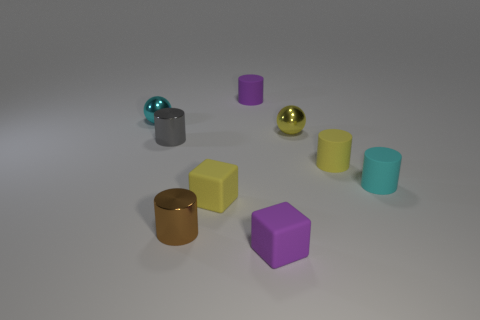The purple object that is in front of the tiny cyan object on the right side of the purple matte block is made of what material?
Make the answer very short. Rubber. How many objects are purple blocks or small rubber cubes?
Your answer should be compact. 2. Is the number of cyan metallic objects less than the number of tiny yellow matte balls?
Provide a short and direct response. No. There is a cylinder that is made of the same material as the small brown object; what size is it?
Ensure brevity in your answer.  Small. The brown metal thing has what size?
Keep it short and to the point. Small. The tiny gray metallic thing has what shape?
Your answer should be very brief. Cylinder. What is the size of the cyan rubber thing that is the same shape as the tiny brown metallic object?
Offer a terse response. Small. Are there any other things that have the same material as the small gray cylinder?
Ensure brevity in your answer.  Yes. There is a cyan thing right of the tiny ball on the left side of the small gray metallic thing; is there a yellow object to the right of it?
Keep it short and to the point. No. There is a cyan object that is in front of the yellow ball; what is it made of?
Provide a short and direct response. Rubber. 